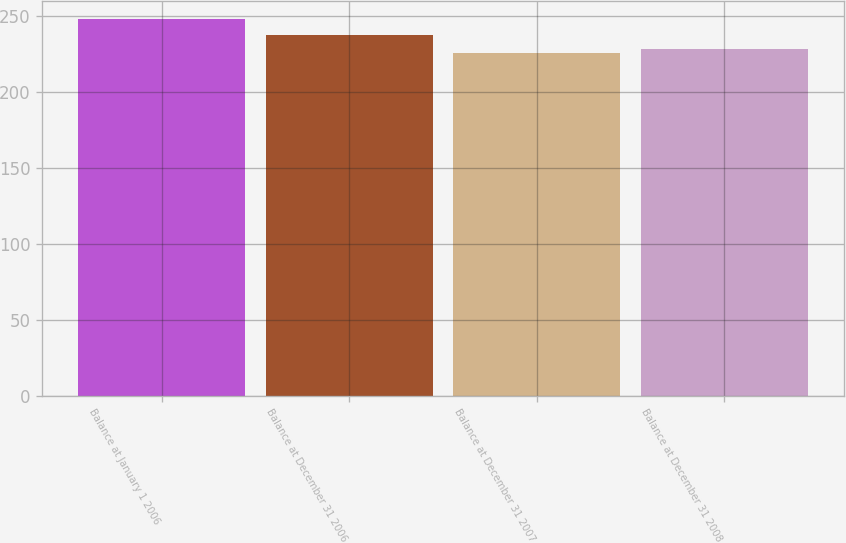Convert chart. <chart><loc_0><loc_0><loc_500><loc_500><bar_chart><fcel>Balance at January 1 2006<fcel>Balance at December 31 2006<fcel>Balance at December 31 2007<fcel>Balance at December 31 2008<nl><fcel>248<fcel>238<fcel>226<fcel>228.2<nl></chart> 